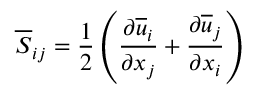Convert formula to latex. <formula><loc_0><loc_0><loc_500><loc_500>\overline { S } _ { i j } = \frac { 1 } { 2 } \left ( \frac { \partial \overline { u } _ { i } } { \partial x _ { j } } + \frac { \partial \overline { u } _ { j } } { \partial x _ { i } } \right )</formula> 